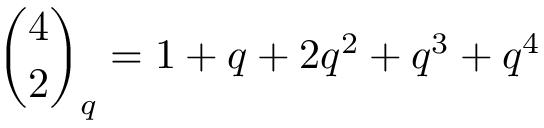Convert formula to latex. <formula><loc_0><loc_0><loc_500><loc_500>{ \binom { 4 } { 2 } } _ { q } = 1 + q + 2 q ^ { 2 } + q ^ { 3 } + q ^ { 4 }</formula> 